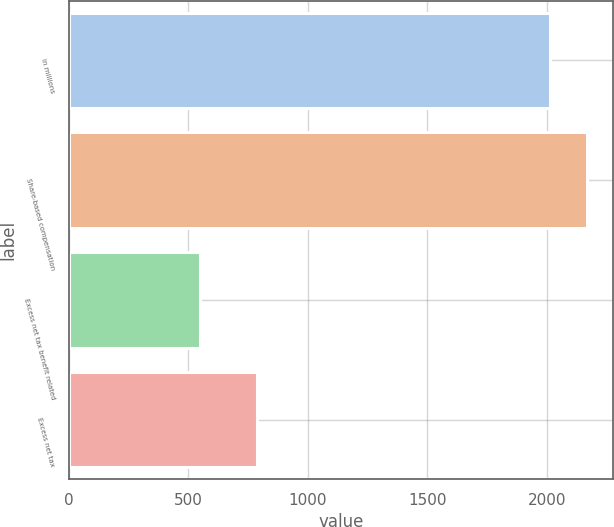Convert chart to OTSL. <chart><loc_0><loc_0><loc_500><loc_500><bar_chart><fcel>in millions<fcel>Share-based compensation<fcel>Excess net tax benefit related<fcel>Excess net tax<nl><fcel>2014<fcel>2169.2<fcel>549<fcel>788<nl></chart> 